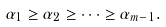Convert formula to latex. <formula><loc_0><loc_0><loc_500><loc_500>\alpha _ { 1 } \geq \alpha _ { 2 } \geq \dots \geq \alpha _ { m - 1 } .</formula> 